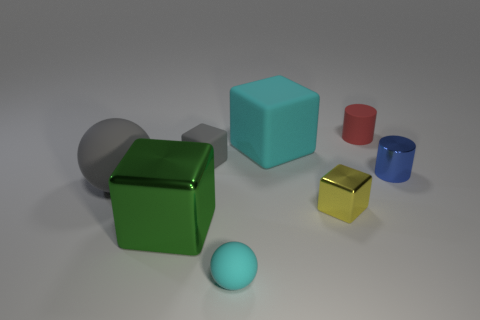Add 1 big gray things. How many objects exist? 9 Subtract all spheres. How many objects are left? 6 Add 3 balls. How many balls are left? 5 Add 3 small shiny things. How many small shiny things exist? 5 Subtract 0 purple cylinders. How many objects are left? 8 Subtract all small red rubber things. Subtract all matte blocks. How many objects are left? 5 